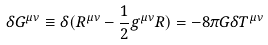Convert formula to latex. <formula><loc_0><loc_0><loc_500><loc_500>\delta G ^ { \mu \nu } \equiv \delta ( R ^ { \mu \nu } - \frac { 1 } { 2 } g ^ { \mu \nu } R ) = - 8 \pi G \delta T ^ { \mu \nu }</formula> 